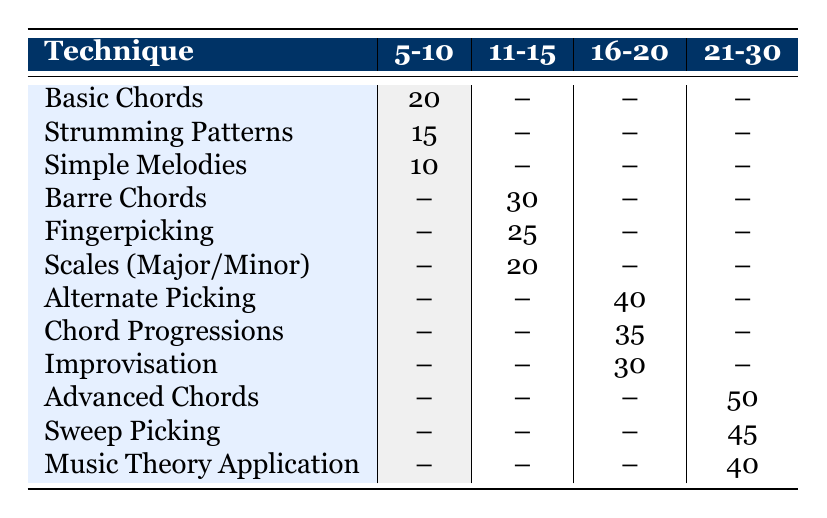What is the practice time for Basic Chords in the 5-10 age group? The table shows that the practice time allocated for Basic Chords in the 5-10 age group is 20 minutes.
Answer: 20 minutes Is there any practice time allocated for Simple Melodies in the 11-15 age group? According to the table, Simple Melodies is listed only under the 5-10 age group, indicating no practice time is allocated for it in the 11-15 age group.
Answer: No What is the total practice time for techniques in the 21-30 age group? To find the total for the 21-30 age group, we sum the practice times: Advanced Chords (50) + Sweep Picking (45) + Music Theory Application (40). That totals 50 + 45 + 40 = 135 minutes.
Answer: 135 minutes True or False: Fingerpicking has the same allocated practice time in the 11-15 age group as Basic Chords in the 5-10 age group. The table indicates that Fingerpicking has a practice time of 25 minutes in the 11-15 age group, while Basic Chords has 20 minutes in the 5-10 age group. Therefore, they do not have the same time allocated.
Answer: False What is the average practice time for all techniques in the 16-20 age group? The techniques and their practice times in the 16-20 age group are: Alternate Picking (40), Chord Progressions (35), and Improvisation (30). To calculate the average, we first sum them: 40 + 35 + 30 = 105. There are 3 techniques, so we divide 105 by 3, giving us an average of 35 minutes.
Answer: 35 minutes Which technique has the highest practice time for the 21-30 age group? Checking the 21-30 age group in the table, Advanced Chords has the highest practice time at 50 minutes, compared to other techniques in the same age group.
Answer: Advanced Chords What is the difference in practice time between Alternate Picking and Chord Progressions? Alternate Picking (40 minutes) and Chord Progressions (35 minutes) are both in the 16-20 age group. The difference is calculated as 40 - 35 = 5 minutes.
Answer: 5 minutes How much practice time is allocated for scales for age groups younger than 16? The table shows that only the 11-15 age group has practice time allocated for Scales (Major/Minor), which is 20 minutes. The 5-10 age group does not include this technique.
Answer: 20 minutes 